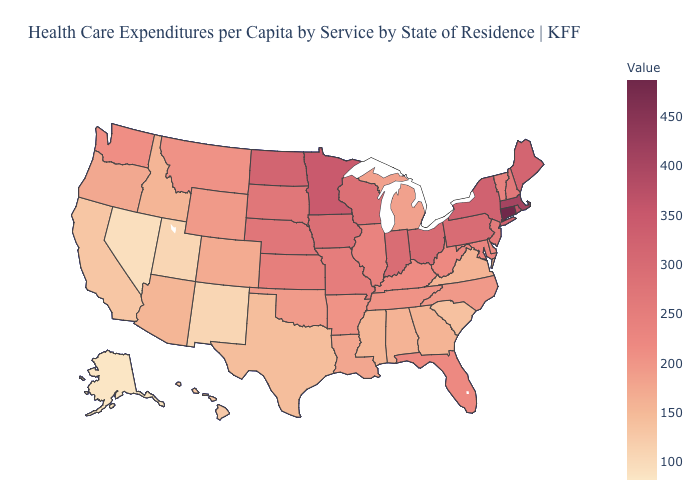Does the map have missing data?
Give a very brief answer. No. Among the states that border Georgia , which have the highest value?
Keep it brief. Florida. Is the legend a continuous bar?
Concise answer only. Yes. Which states hav the highest value in the Northeast?
Write a very short answer. Connecticut. Which states hav the highest value in the West?
Be succinct. Washington. 